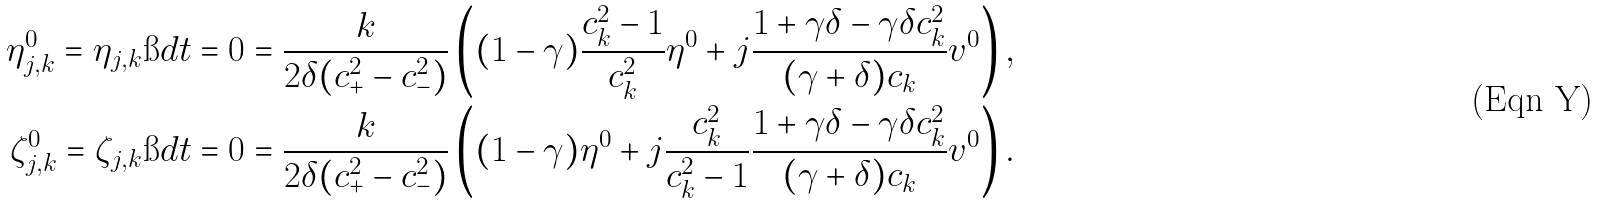<formula> <loc_0><loc_0><loc_500><loc_500>\eta _ { j , k } ^ { 0 } = { \eta _ { j , k } } \i d { t = 0 } & = \frac { k } { 2 \delta ( c _ { + } ^ { 2 } - c _ { - } ^ { 2 } ) } \left ( ( 1 - \gamma ) \frac { c _ { k } ^ { 2 } - 1 } { c _ { k } ^ { 2 } } \eta ^ { 0 } + j \frac { 1 + \gamma \delta - \gamma \delta c _ { k } ^ { 2 } } { ( \gamma + \delta ) c _ { k } } v ^ { 0 } \right ) , \\ \zeta _ { j , k } ^ { 0 } = { \zeta _ { j , k } } \i d { t = 0 } & = \frac { k } { 2 \delta ( c _ { + } ^ { 2 } - c _ { - } ^ { 2 } ) } \left ( ( 1 - \gamma ) \eta ^ { 0 } + j \frac { c _ { k } ^ { 2 } } { c _ { k } ^ { 2 } - 1 } \frac { 1 + \gamma \delta - \gamma \delta c _ { k } ^ { 2 } } { ( \gamma + \delta ) c _ { k } } v ^ { 0 } \right ) .</formula> 